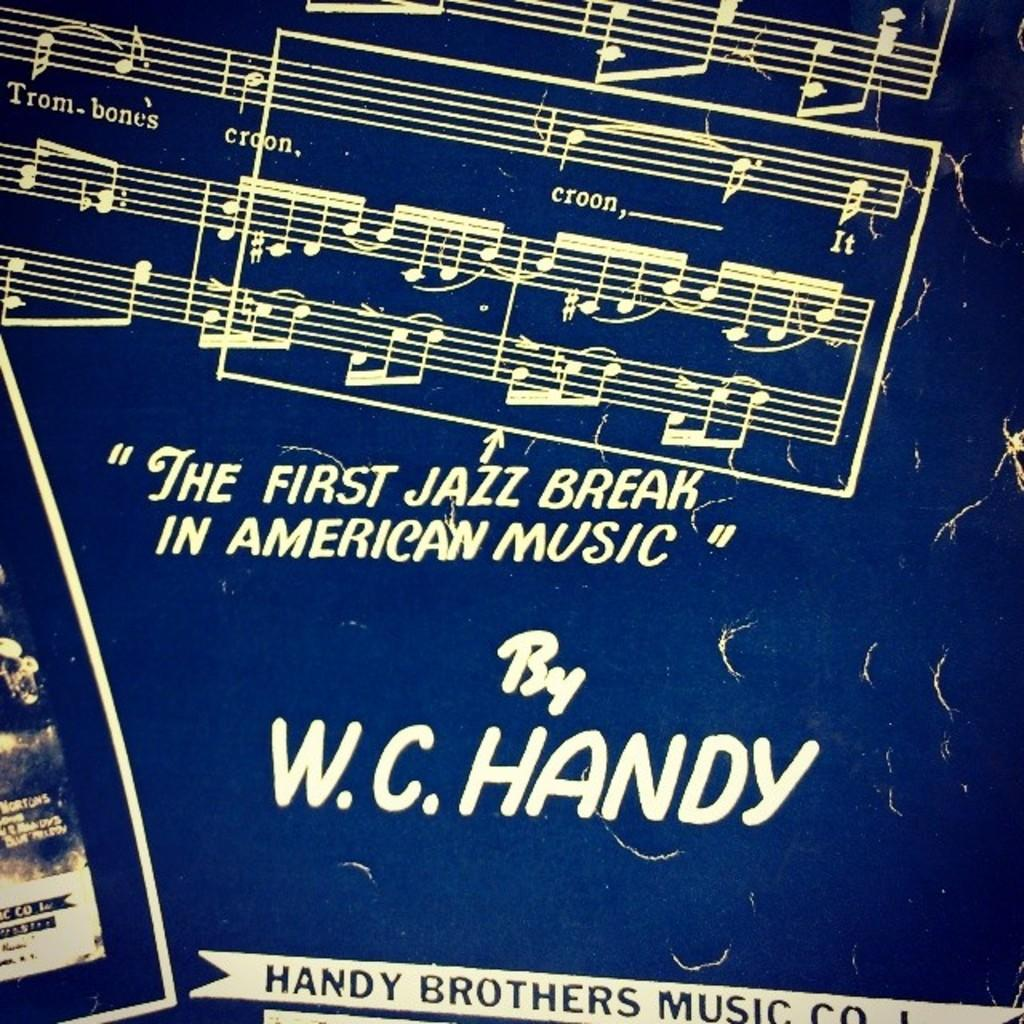<image>
Summarize the visual content of the image. An album by W.C. Handy says it is the first jazz break in American music. 